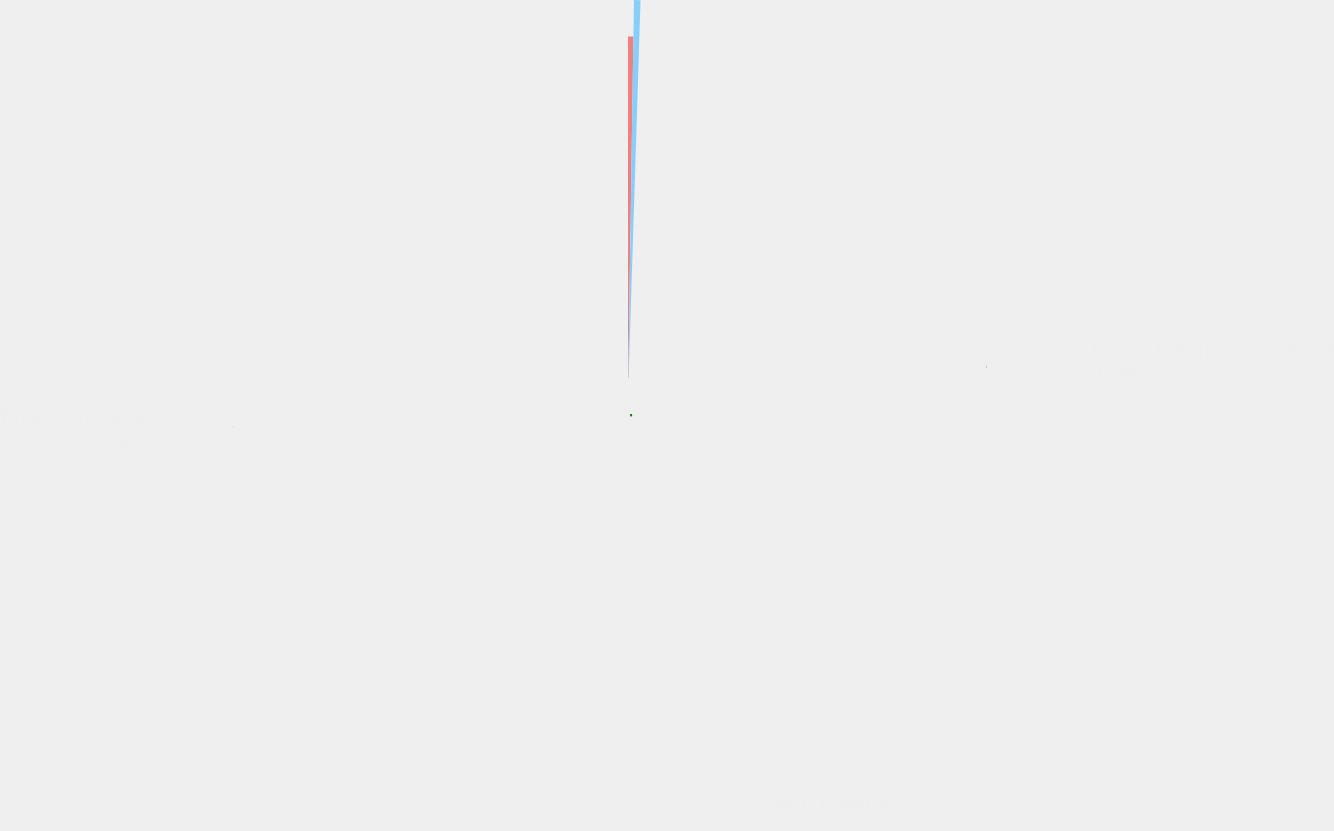<chart> <loc_0><loc_0><loc_500><loc_500><pie_chart><fcel>Power Purchase Contract<fcel>Current Liabilities<fcel>Total Commodity Derivatives<nl><fcel>47.44%<fcel>0.06%<fcel>52.5%<nl></chart> 